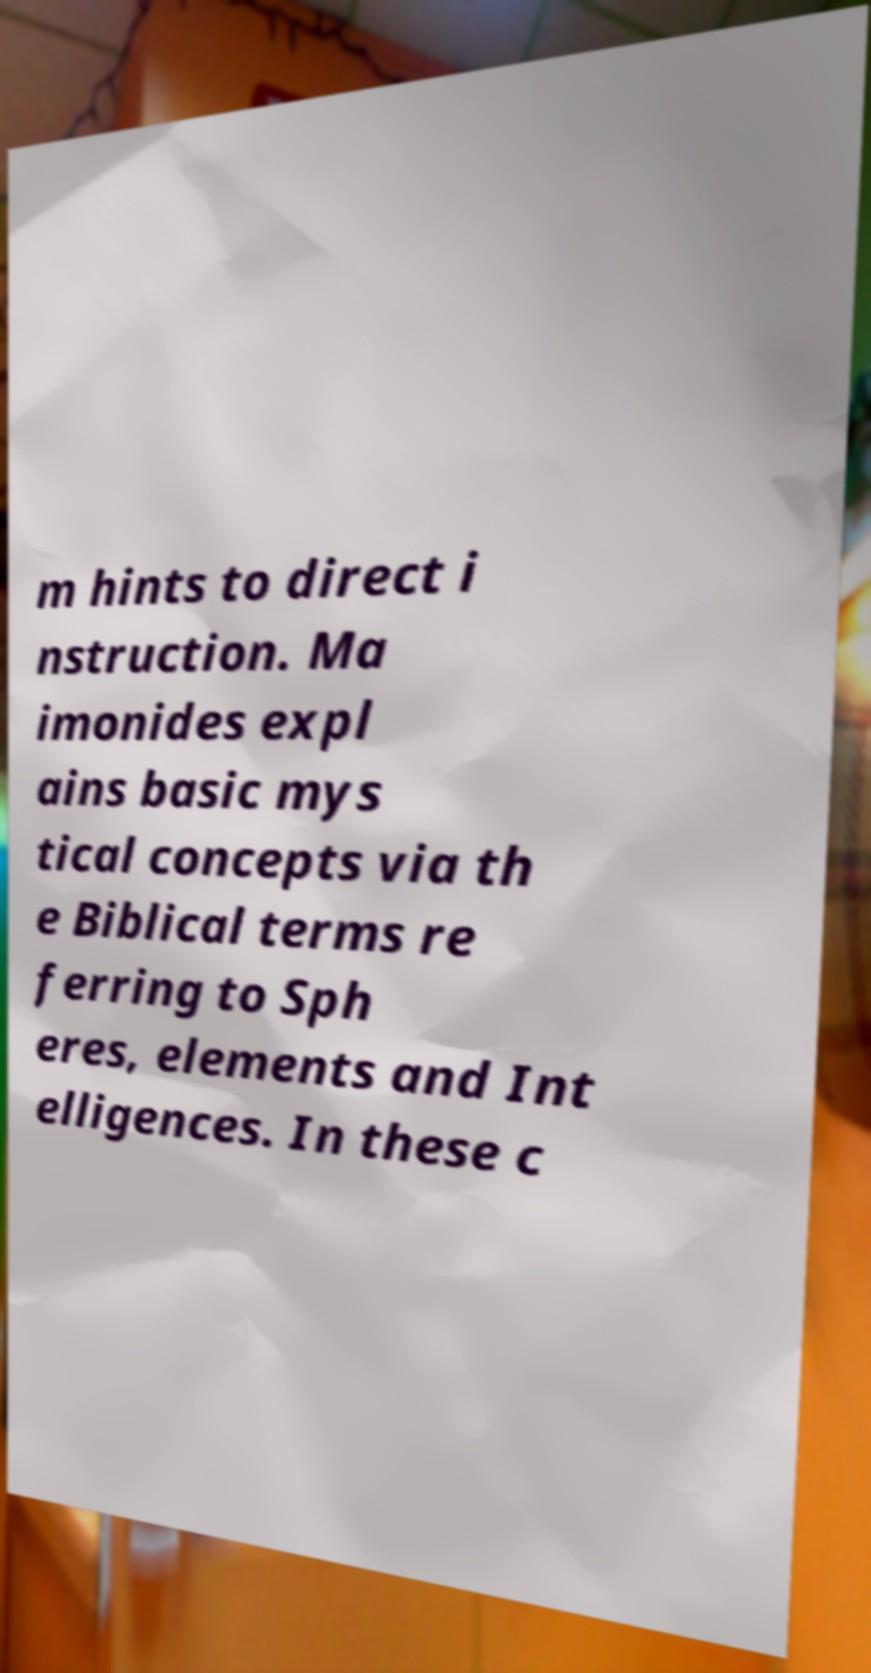Can you read and provide the text displayed in the image?This photo seems to have some interesting text. Can you extract and type it out for me? m hints to direct i nstruction. Ma imonides expl ains basic mys tical concepts via th e Biblical terms re ferring to Sph eres, elements and Int elligences. In these c 